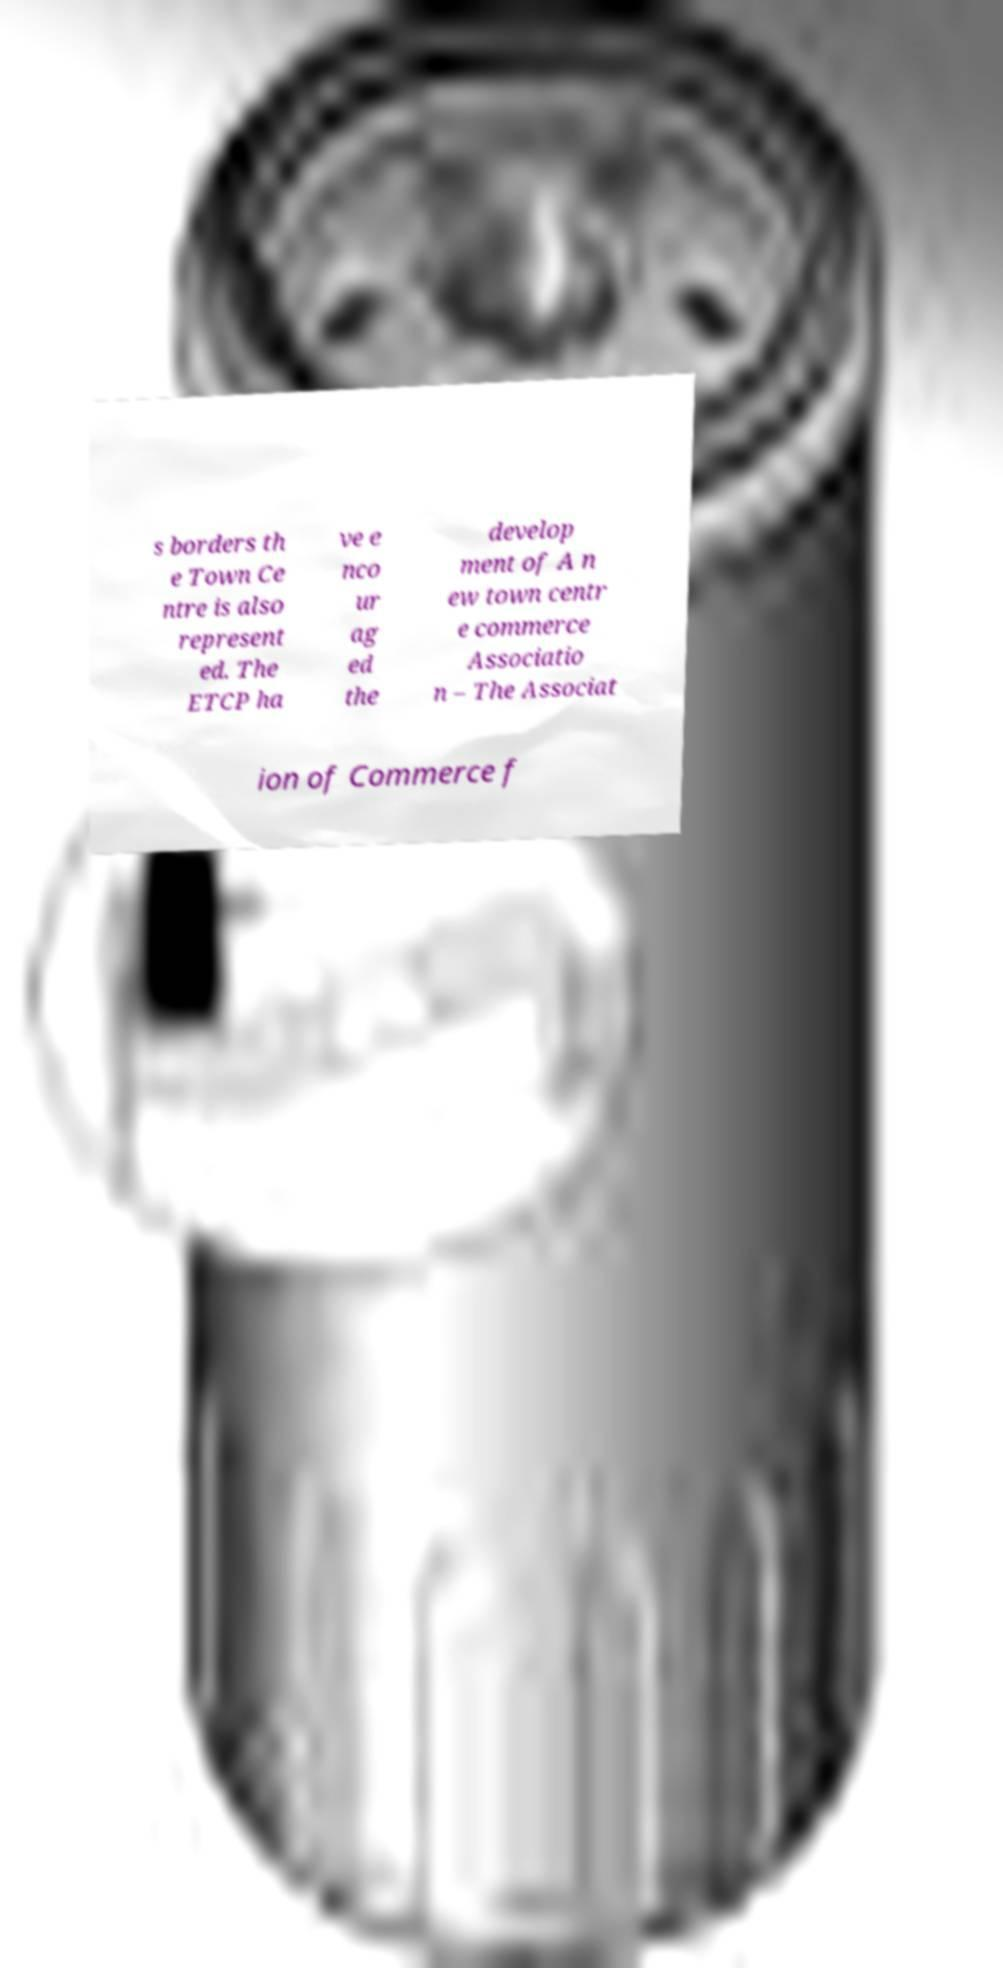I need the written content from this picture converted into text. Can you do that? s borders th e Town Ce ntre is also represent ed. The ETCP ha ve e nco ur ag ed the develop ment of A n ew town centr e commerce Associatio n – The Associat ion of Commerce f 